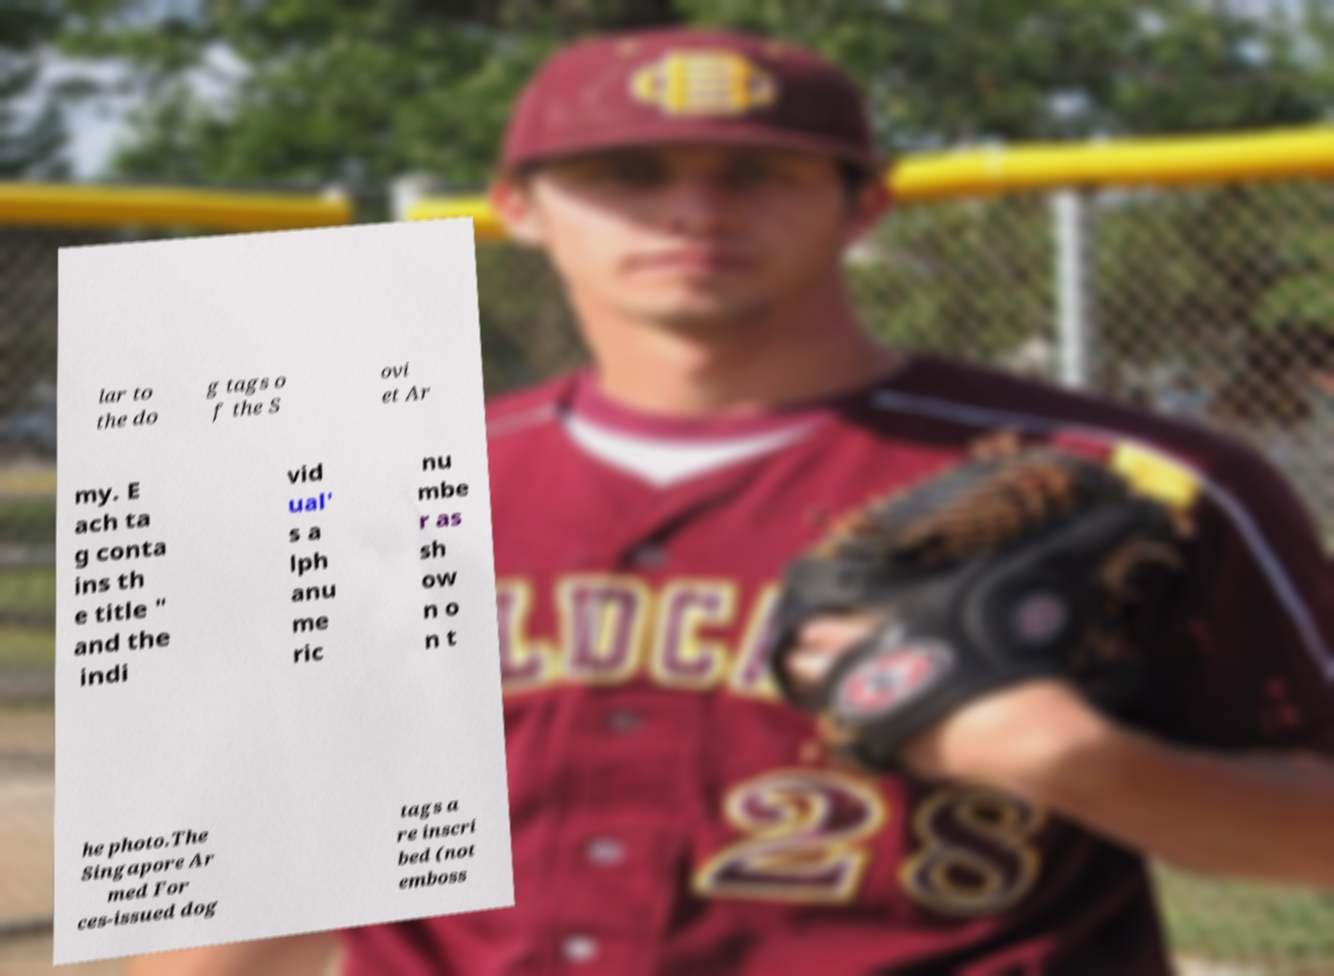Can you accurately transcribe the text from the provided image for me? lar to the do g tags o f the S ovi et Ar my. E ach ta g conta ins th e title " and the indi vid ual' s a lph anu me ric nu mbe r as sh ow n o n t he photo.The Singapore Ar med For ces-issued dog tags a re inscri bed (not emboss 